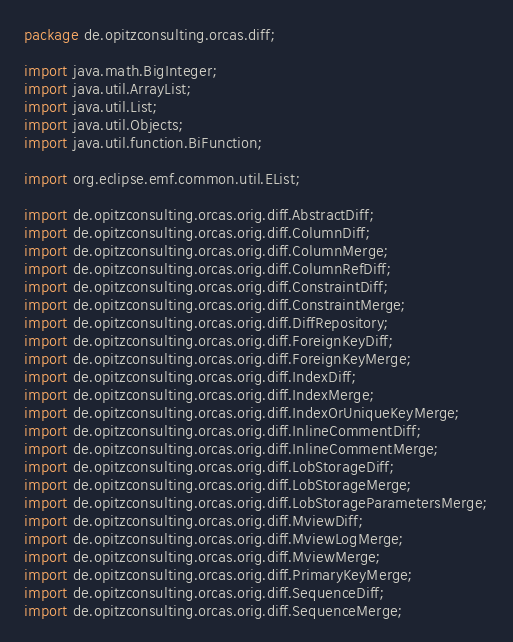<code> <loc_0><loc_0><loc_500><loc_500><_Java_>package de.opitzconsulting.orcas.diff;

import java.math.BigInteger;
import java.util.ArrayList;
import java.util.List;
import java.util.Objects;
import java.util.function.BiFunction;

import org.eclipse.emf.common.util.EList;

import de.opitzconsulting.orcas.orig.diff.AbstractDiff;
import de.opitzconsulting.orcas.orig.diff.ColumnDiff;
import de.opitzconsulting.orcas.orig.diff.ColumnMerge;
import de.opitzconsulting.orcas.orig.diff.ColumnRefDiff;
import de.opitzconsulting.orcas.orig.diff.ConstraintDiff;
import de.opitzconsulting.orcas.orig.diff.ConstraintMerge;
import de.opitzconsulting.orcas.orig.diff.DiffRepository;
import de.opitzconsulting.orcas.orig.diff.ForeignKeyDiff;
import de.opitzconsulting.orcas.orig.diff.ForeignKeyMerge;
import de.opitzconsulting.orcas.orig.diff.IndexDiff;
import de.opitzconsulting.orcas.orig.diff.IndexMerge;
import de.opitzconsulting.orcas.orig.diff.IndexOrUniqueKeyMerge;
import de.opitzconsulting.orcas.orig.diff.InlineCommentDiff;
import de.opitzconsulting.orcas.orig.diff.InlineCommentMerge;
import de.opitzconsulting.orcas.orig.diff.LobStorageDiff;
import de.opitzconsulting.orcas.orig.diff.LobStorageMerge;
import de.opitzconsulting.orcas.orig.diff.LobStorageParametersMerge;
import de.opitzconsulting.orcas.orig.diff.MviewDiff;
import de.opitzconsulting.orcas.orig.diff.MviewLogMerge;
import de.opitzconsulting.orcas.orig.diff.MviewMerge;
import de.opitzconsulting.orcas.orig.diff.PrimaryKeyMerge;
import de.opitzconsulting.orcas.orig.diff.SequenceDiff;
import de.opitzconsulting.orcas.orig.diff.SequenceMerge;</code> 